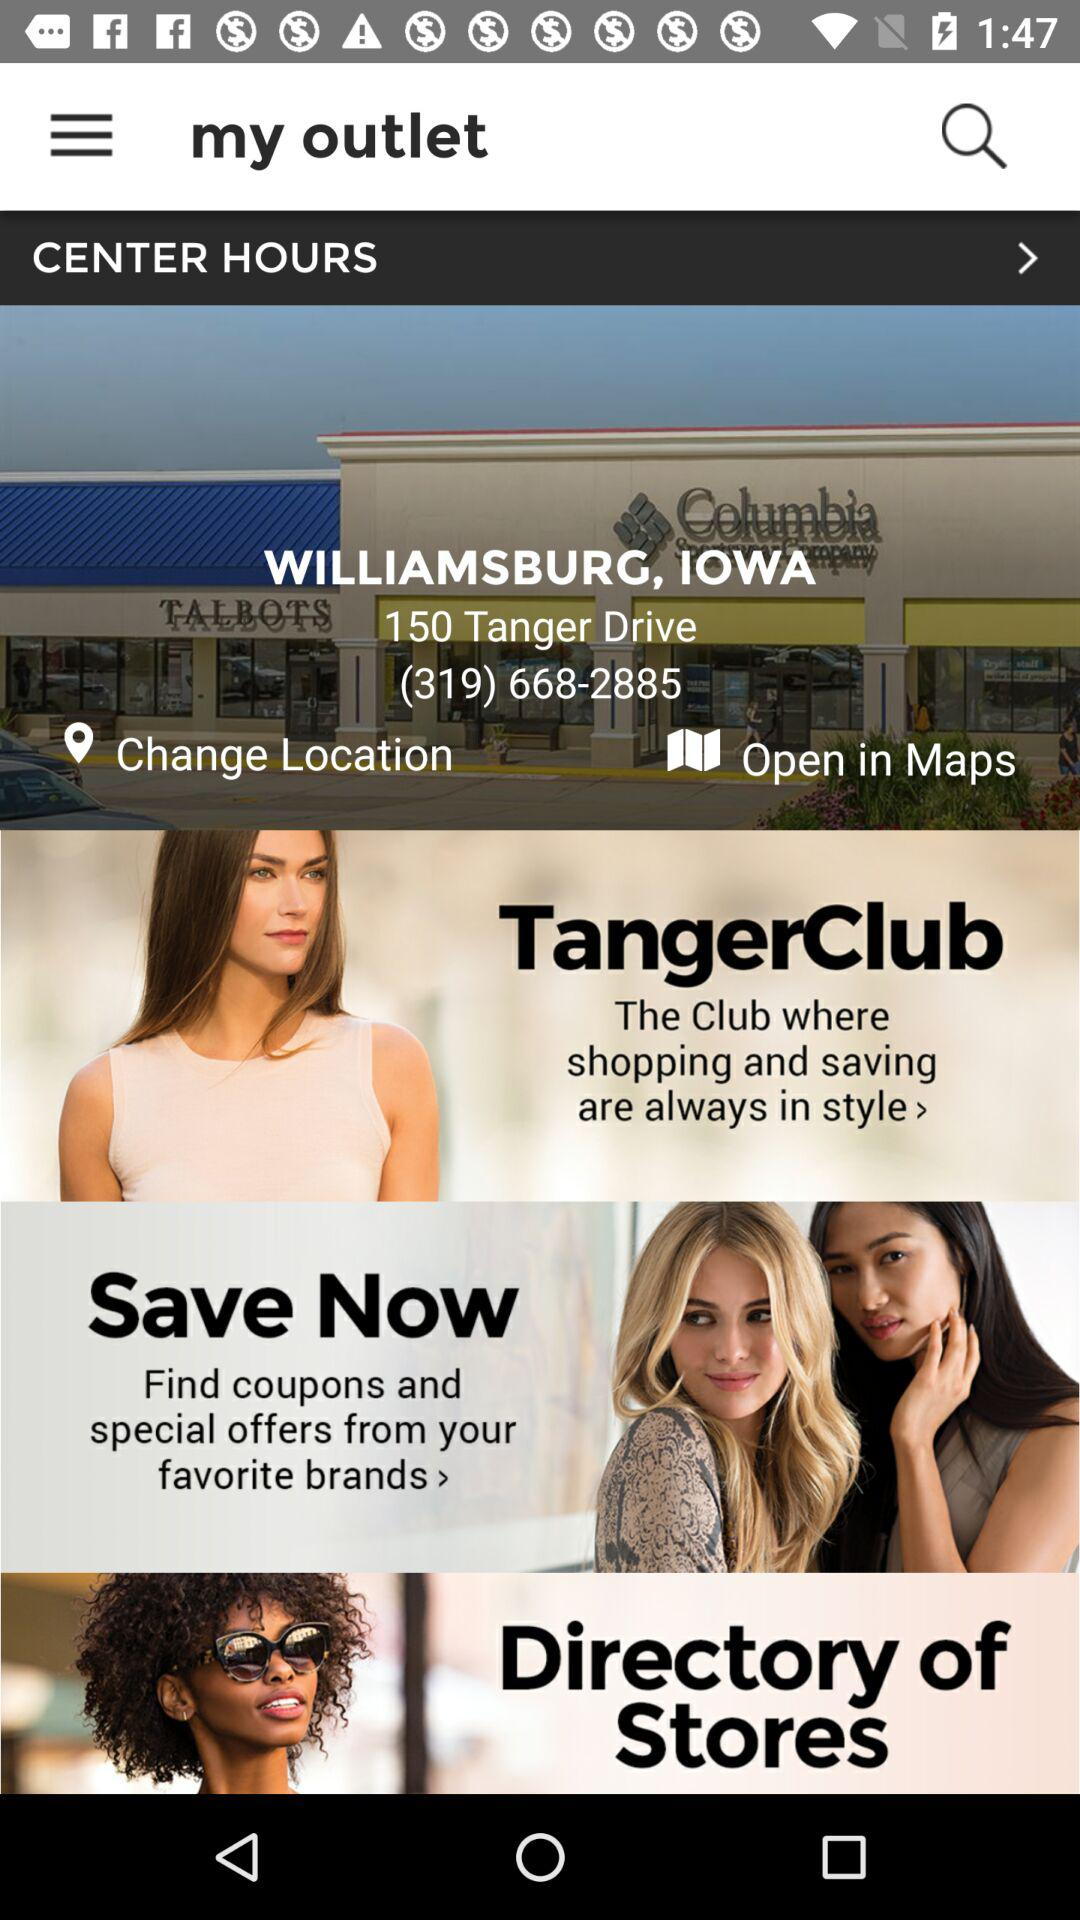Where is the address? The address is 150 Tanger Drive, WILLIAMSBURG, IOWA. 